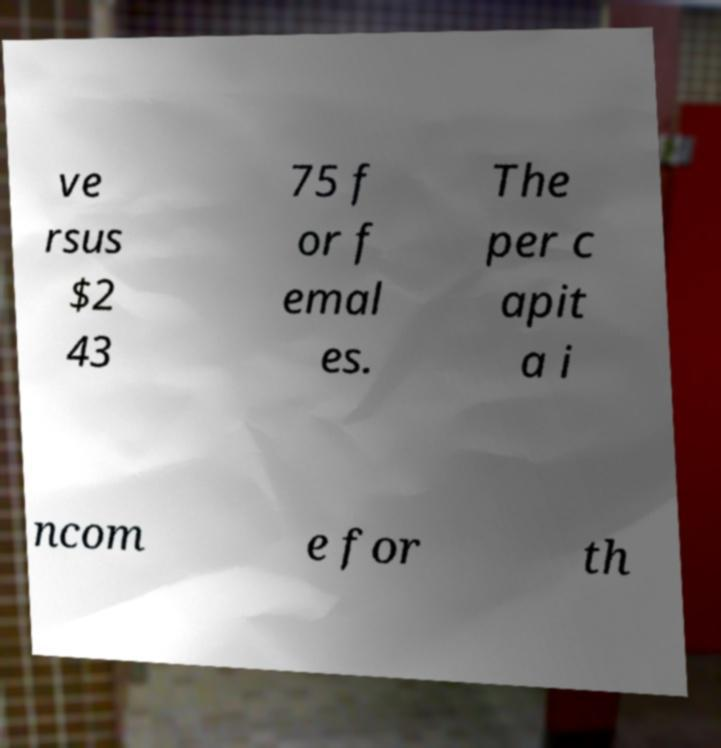What messages or text are displayed in this image? I need them in a readable, typed format. ve rsus $2 43 75 f or f emal es. The per c apit a i ncom e for th 